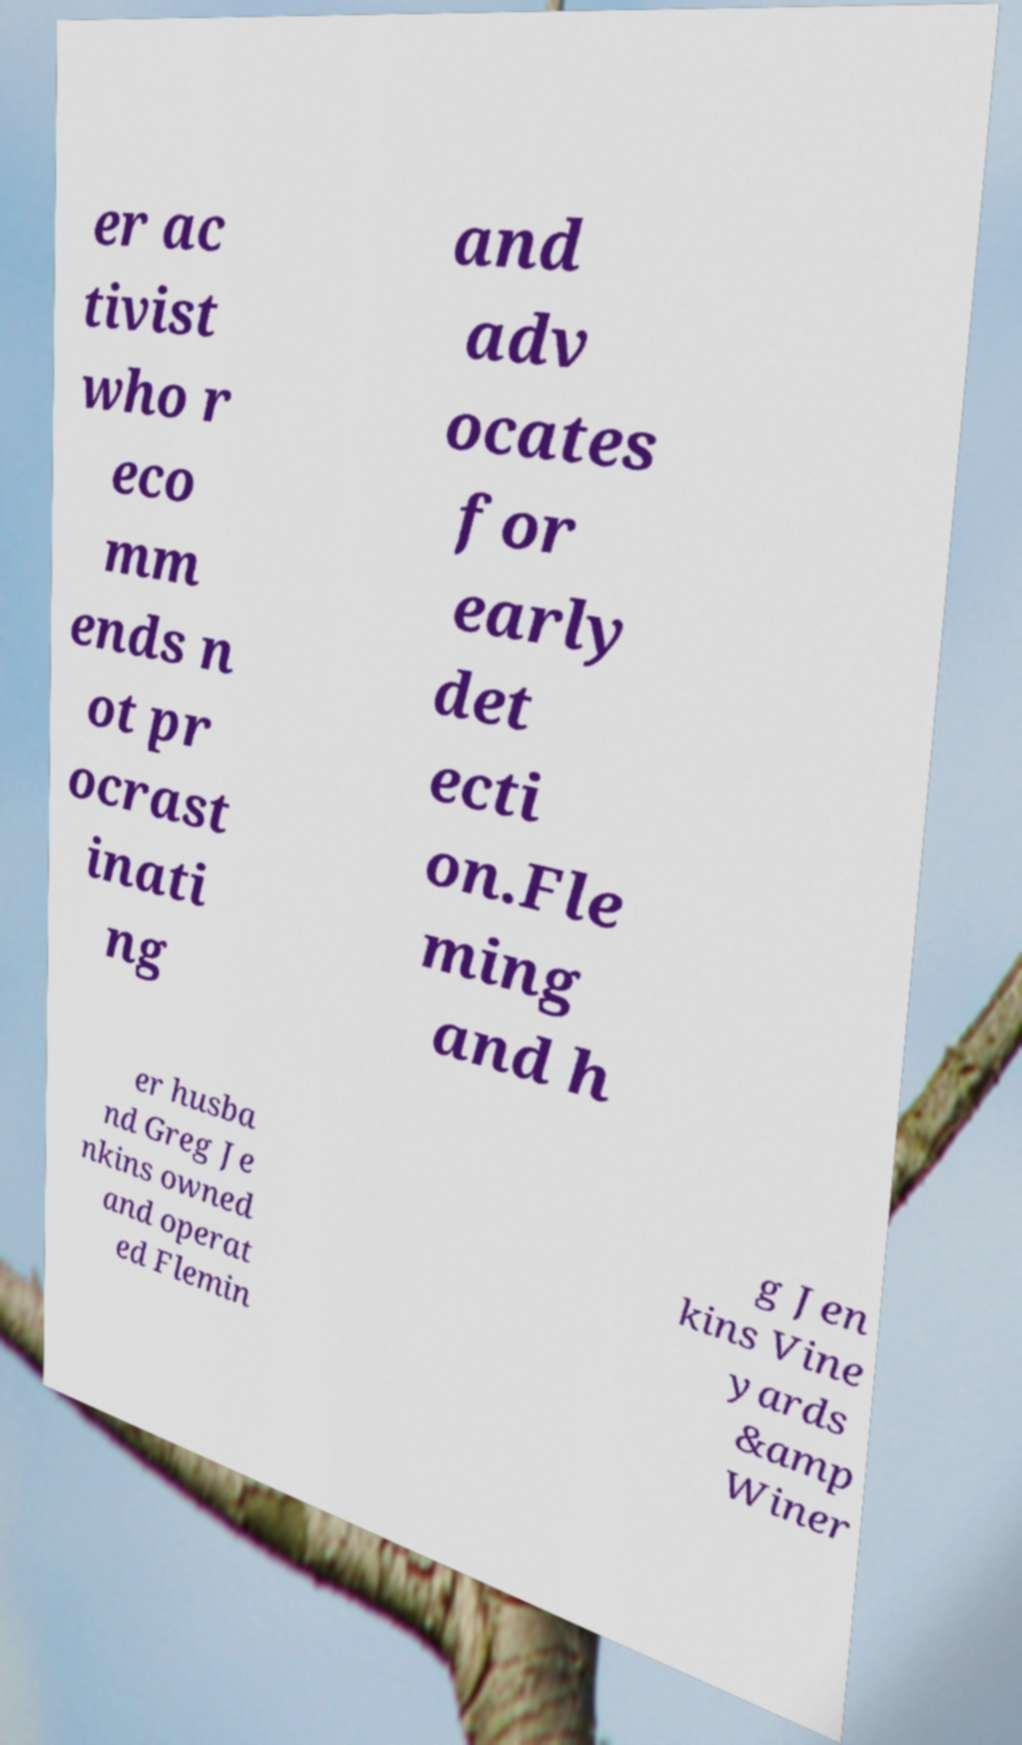Please read and relay the text visible in this image. What does it say? er ac tivist who r eco mm ends n ot pr ocrast inati ng and adv ocates for early det ecti on.Fle ming and h er husba nd Greg Je nkins owned and operat ed Flemin g Jen kins Vine yards &amp Winer 